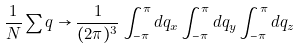Convert formula to latex. <formula><loc_0><loc_0><loc_500><loc_500>\frac { 1 } { N } \sum _ { \ } q \rightarrow \frac { 1 } { ( 2 \pi ) ^ { 3 } } \int ^ { \pi } _ { - \pi } d q _ { x } \int ^ { \pi } _ { - \pi } d q _ { y } \int ^ { \pi } _ { - \pi } d q _ { z }</formula> 